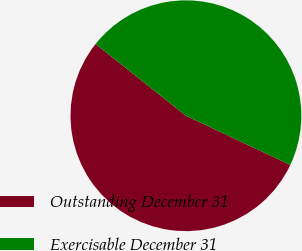Convert chart to OTSL. <chart><loc_0><loc_0><loc_500><loc_500><pie_chart><fcel>Outstanding December 31<fcel>Exercisable December 31<nl><fcel>53.67%<fcel>46.33%<nl></chart> 